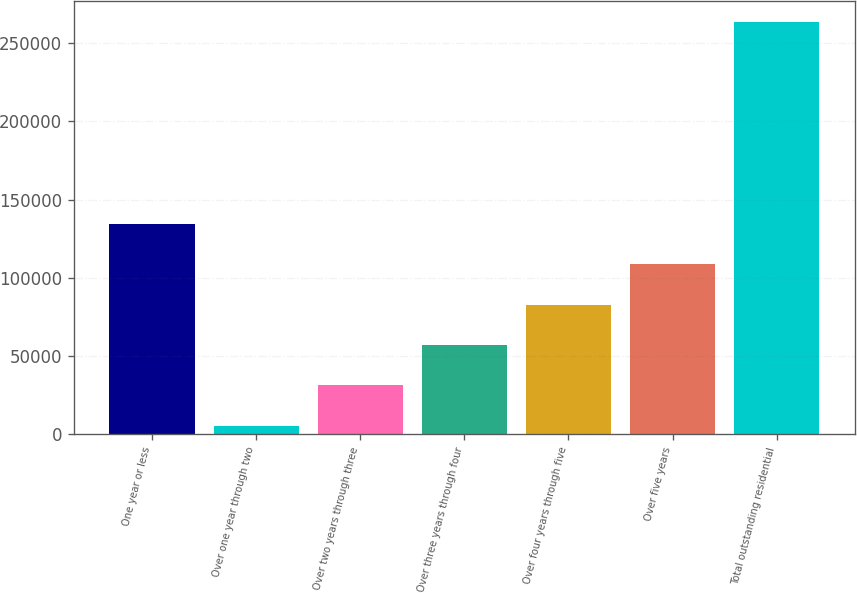Convert chart. <chart><loc_0><loc_0><loc_500><loc_500><bar_chart><fcel>One year or less<fcel>Over one year through two<fcel>Over two years through three<fcel>Over three years through four<fcel>Over four years through five<fcel>Over five years<fcel>Total outstanding residential<nl><fcel>134527<fcel>5407<fcel>31231<fcel>57055<fcel>82879<fcel>108703<fcel>263647<nl></chart> 